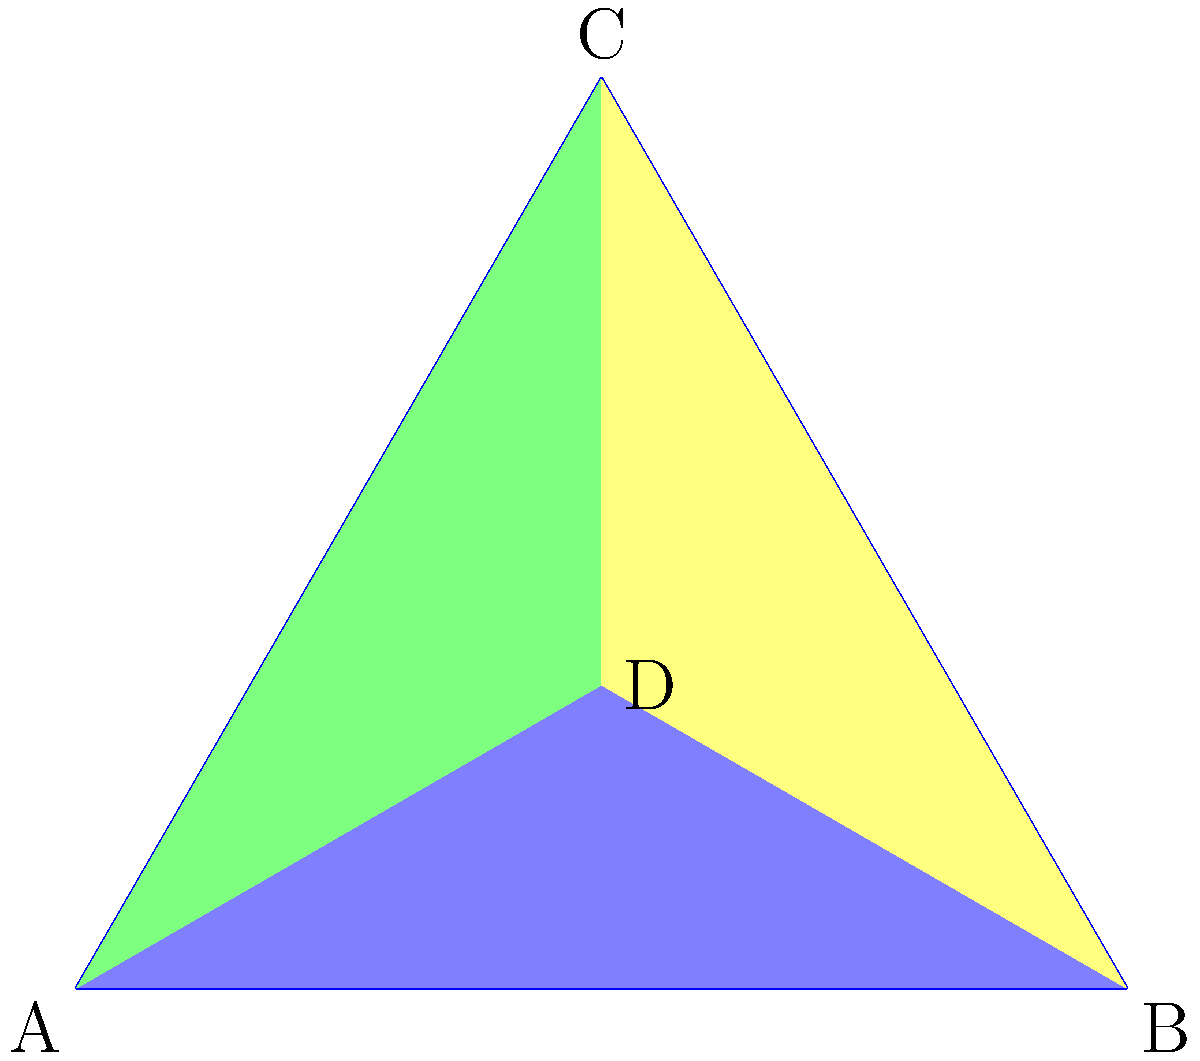In the context of modeling team dynamics using simplicial complexes, consider the tetrahedron ABCD shown above. Each vertex represents a player, and each face represents a specific aspect of team interaction. If we remove vertex D and its associated faces, what is the Euler characteristic of the resulting simplicial complex, and how might this change in topology relate to team cohesion? To answer this question, we need to follow these steps:

1. Understand the initial structure:
   - The tetrahedron ABCD is a 3-simplex with 4 vertices, 6 edges, and 4 faces.
   - Its Euler characteristic is $\chi = V - E + F = 4 - 6 + 4 = 2$.

2. Remove vertex D and associated faces:
   - Removing D eliminates 1 vertex, 3 edges (AD, BD, CD), and 3 faces (ABD, ACD, BCD).
   - The resulting structure is a triangle ABC.

3. Calculate the new Euler characteristic:
   - New vertex count: $V' = 3$
   - New edge count: $E' = 3$
   - New face count: $F' = 1$
   - New Euler characteristic: $\chi' = V' - E' + F' = 3 - 3 + 1 = 1$

4. Interpret the change in topology:
   - The Euler characteristic changed from 2 to 1.
   - This represents a simplification of the structure from a 3D object to a 2D object.
   - In team dynamics, this could be interpreted as a reduction in complexity and interconnectedness.

5. Relate to team cohesion:
   - The removal of a vertex (player) has reduced the dimensionality of interactions.
   - This might indicate a decrease in team cohesion, as there are fewer multi-player interactions.
   - The team structure has become simpler, which could mean less adaptability or reduced capability to handle complex situations.

The change in Euler characteristic (from 2 to 1) quantifies the topological change, serving as a metric for the impact on team structure and potentially on team cohesion.
Answer: $\chi' = 1$; indicates reduced complexity and potential decrease in team cohesion. 